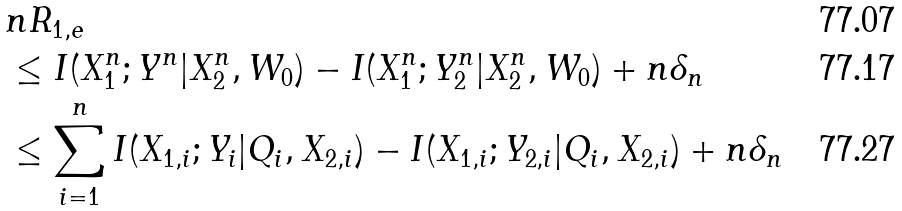Convert formula to latex. <formula><loc_0><loc_0><loc_500><loc_500>& n R _ { 1 , e } \\ & \leq I ( X _ { 1 } ^ { n } ; Y ^ { n } | X _ { 2 } ^ { n } , W _ { 0 } ) - I ( X _ { 1 } ^ { n } ; Y _ { 2 } ^ { n } | X _ { 2 } ^ { n } , W _ { 0 } ) + n \delta _ { n } \\ & \leq \sum _ { i = 1 } ^ { n } I ( X _ { 1 , i } ; Y _ { i } | Q _ { i } , X _ { 2 , i } ) - I ( X _ { 1 , i } ; Y _ { 2 , i } | Q _ { i } , X _ { 2 , i } ) + n \delta _ { n }</formula> 